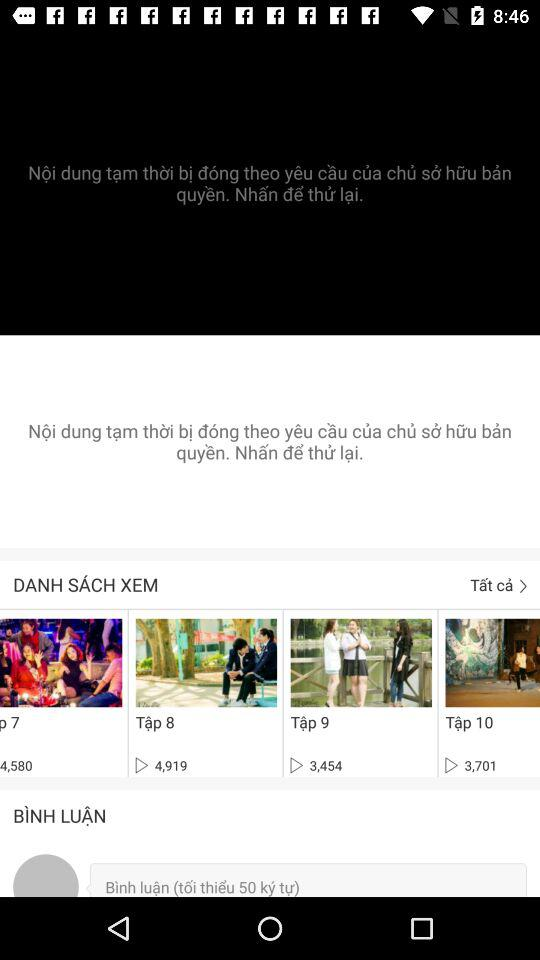How many episodes have more than 4000 views?
Answer the question using a single word or phrase. 2 